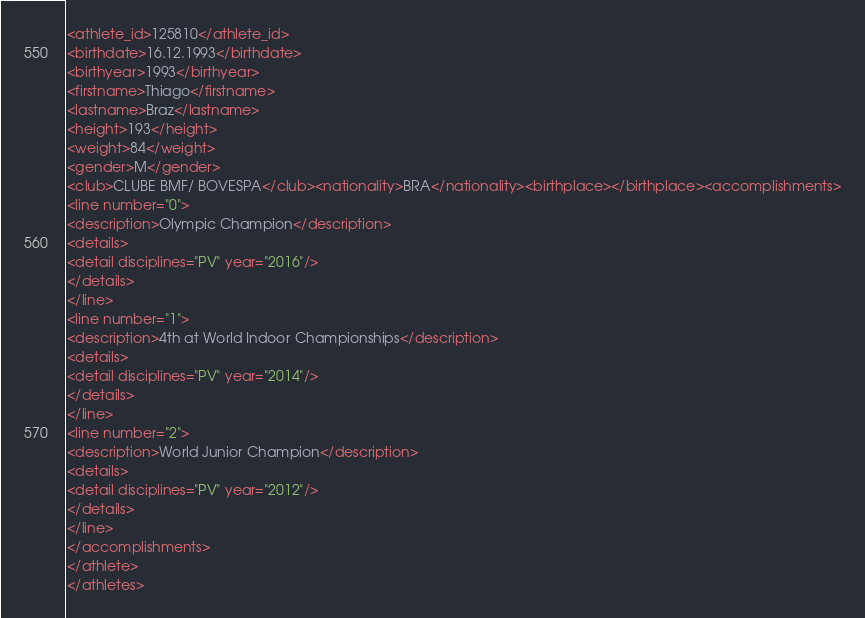<code> <loc_0><loc_0><loc_500><loc_500><_XML_><athlete_id>125810</athlete_id>
<birthdate>16.12.1993</birthdate>
<birthyear>1993</birthyear>
<firstname>Thiago</firstname>
<lastname>Braz</lastname>
<height>193</height>
<weight>84</weight>
<gender>M</gender>
<club>CLUBE BMF/ BOVESPA</club><nationality>BRA</nationality><birthplace></birthplace><accomplishments>
<line number="0">
<description>Olympic Champion</description>
<details>
<detail disciplines="PV" year="2016"/>
</details>
</line>
<line number="1">
<description>4th at World Indoor Championships</description>
<details>
<detail disciplines="PV" year="2014"/>
</details>
</line>
<line number="2">
<description>World Junior Champion</description>
<details>
<detail disciplines="PV" year="2012"/>
</details>
</line>
</accomplishments>
</athlete>
</athletes>
</code> 